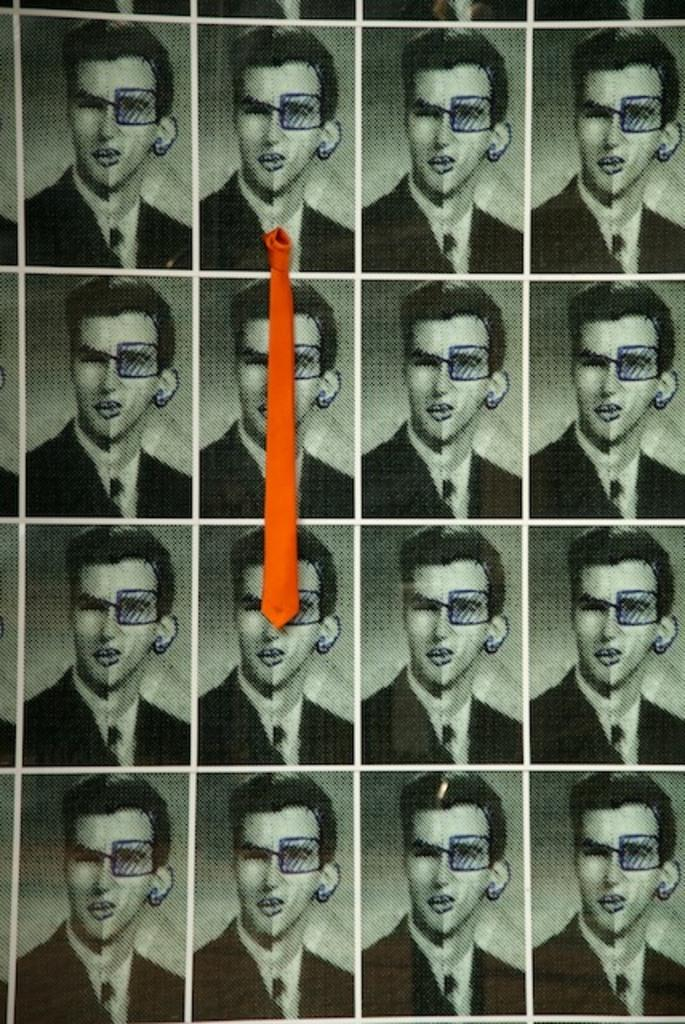What is depicted on the paper in the image? There are images of a person on paper. What type of clothing accessory is visible in the image? There is a tie visible in the image. What is the best route to take to reach the linen store in the image? There is no information about a linen store or a route in the image. What type of stew is being prepared in the image? There is no stew or any cooking activity present in the image. 